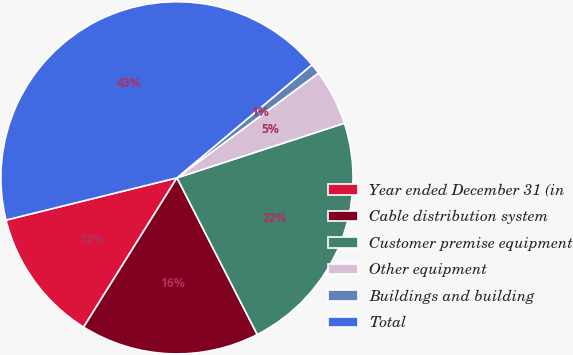<chart> <loc_0><loc_0><loc_500><loc_500><pie_chart><fcel>Year ended December 31 (in<fcel>Cable distribution system<fcel>Customer premise equipment<fcel>Other equipment<fcel>Buildings and building<fcel>Total<nl><fcel>12.25%<fcel>16.43%<fcel>22.48%<fcel>5.13%<fcel>0.95%<fcel>42.76%<nl></chart> 